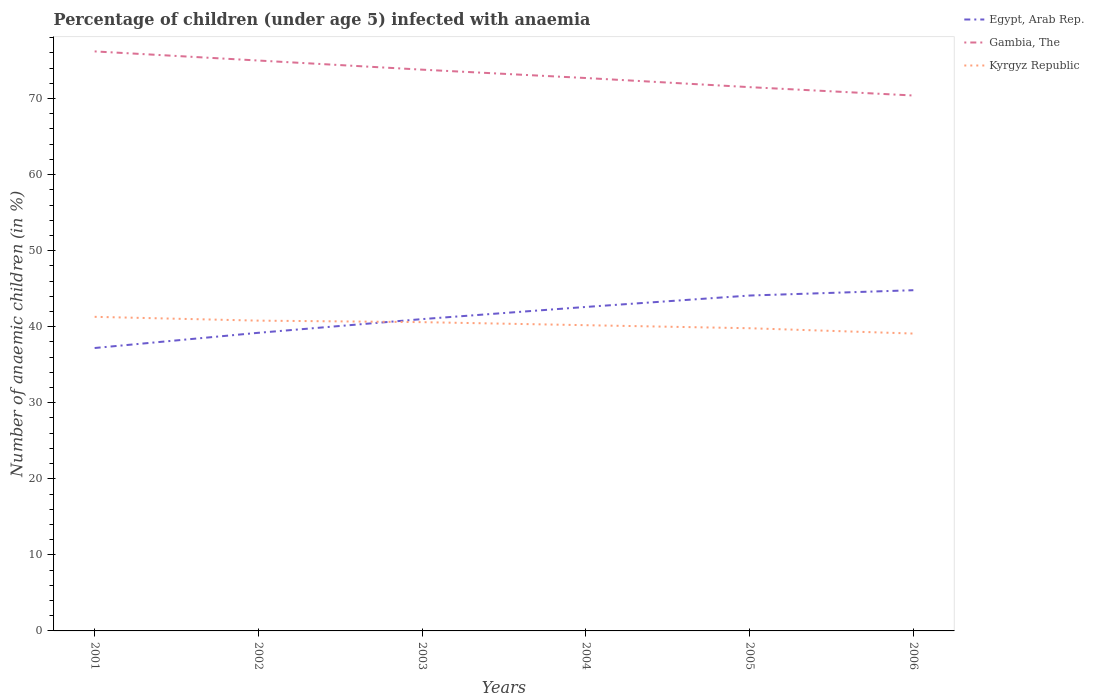How many different coloured lines are there?
Your answer should be compact. 3. Is the number of lines equal to the number of legend labels?
Offer a very short reply. Yes. Across all years, what is the maximum percentage of children infected with anaemia in in Gambia, The?
Keep it short and to the point. 70.4. In which year was the percentage of children infected with anaemia in in Kyrgyz Republic maximum?
Provide a short and direct response. 2006. What is the total percentage of children infected with anaemia in in Kyrgyz Republic in the graph?
Ensure brevity in your answer.  1.1. What is the difference between the highest and the second highest percentage of children infected with anaemia in in Egypt, Arab Rep.?
Provide a succinct answer. 7.6. How many years are there in the graph?
Offer a very short reply. 6. What is the difference between two consecutive major ticks on the Y-axis?
Provide a short and direct response. 10. Are the values on the major ticks of Y-axis written in scientific E-notation?
Ensure brevity in your answer.  No. Does the graph contain any zero values?
Keep it short and to the point. No. How many legend labels are there?
Offer a terse response. 3. What is the title of the graph?
Your response must be concise. Percentage of children (under age 5) infected with anaemia. What is the label or title of the Y-axis?
Give a very brief answer. Number of anaemic children (in %). What is the Number of anaemic children (in %) in Egypt, Arab Rep. in 2001?
Your response must be concise. 37.2. What is the Number of anaemic children (in %) of Gambia, The in 2001?
Offer a terse response. 76.2. What is the Number of anaemic children (in %) of Kyrgyz Republic in 2001?
Offer a very short reply. 41.3. What is the Number of anaemic children (in %) in Egypt, Arab Rep. in 2002?
Offer a terse response. 39.2. What is the Number of anaemic children (in %) in Gambia, The in 2002?
Offer a terse response. 75. What is the Number of anaemic children (in %) of Kyrgyz Republic in 2002?
Ensure brevity in your answer.  40.8. What is the Number of anaemic children (in %) of Egypt, Arab Rep. in 2003?
Ensure brevity in your answer.  41. What is the Number of anaemic children (in %) in Gambia, The in 2003?
Your answer should be very brief. 73.8. What is the Number of anaemic children (in %) of Kyrgyz Republic in 2003?
Your response must be concise. 40.6. What is the Number of anaemic children (in %) of Egypt, Arab Rep. in 2004?
Keep it short and to the point. 42.6. What is the Number of anaemic children (in %) in Gambia, The in 2004?
Your answer should be compact. 72.7. What is the Number of anaemic children (in %) in Kyrgyz Republic in 2004?
Make the answer very short. 40.2. What is the Number of anaemic children (in %) in Egypt, Arab Rep. in 2005?
Provide a succinct answer. 44.1. What is the Number of anaemic children (in %) in Gambia, The in 2005?
Give a very brief answer. 71.5. What is the Number of anaemic children (in %) of Kyrgyz Republic in 2005?
Provide a short and direct response. 39.8. What is the Number of anaemic children (in %) in Egypt, Arab Rep. in 2006?
Make the answer very short. 44.8. What is the Number of anaemic children (in %) in Gambia, The in 2006?
Your answer should be very brief. 70.4. What is the Number of anaemic children (in %) in Kyrgyz Republic in 2006?
Ensure brevity in your answer.  39.1. Across all years, what is the maximum Number of anaemic children (in %) of Egypt, Arab Rep.?
Provide a succinct answer. 44.8. Across all years, what is the maximum Number of anaemic children (in %) in Gambia, The?
Your answer should be very brief. 76.2. Across all years, what is the maximum Number of anaemic children (in %) in Kyrgyz Republic?
Offer a very short reply. 41.3. Across all years, what is the minimum Number of anaemic children (in %) in Egypt, Arab Rep.?
Your answer should be very brief. 37.2. Across all years, what is the minimum Number of anaemic children (in %) in Gambia, The?
Your answer should be compact. 70.4. Across all years, what is the minimum Number of anaemic children (in %) in Kyrgyz Republic?
Make the answer very short. 39.1. What is the total Number of anaemic children (in %) in Egypt, Arab Rep. in the graph?
Your answer should be compact. 248.9. What is the total Number of anaemic children (in %) of Gambia, The in the graph?
Give a very brief answer. 439.6. What is the total Number of anaemic children (in %) of Kyrgyz Republic in the graph?
Keep it short and to the point. 241.8. What is the difference between the Number of anaemic children (in %) of Gambia, The in 2001 and that in 2002?
Make the answer very short. 1.2. What is the difference between the Number of anaemic children (in %) of Gambia, The in 2001 and that in 2003?
Give a very brief answer. 2.4. What is the difference between the Number of anaemic children (in %) in Kyrgyz Republic in 2001 and that in 2004?
Keep it short and to the point. 1.1. What is the difference between the Number of anaemic children (in %) of Kyrgyz Republic in 2001 and that in 2005?
Your answer should be compact. 1.5. What is the difference between the Number of anaemic children (in %) of Kyrgyz Republic in 2001 and that in 2006?
Give a very brief answer. 2.2. What is the difference between the Number of anaemic children (in %) in Egypt, Arab Rep. in 2002 and that in 2004?
Give a very brief answer. -3.4. What is the difference between the Number of anaemic children (in %) in Gambia, The in 2002 and that in 2006?
Provide a short and direct response. 4.6. What is the difference between the Number of anaemic children (in %) in Kyrgyz Republic in 2002 and that in 2006?
Offer a very short reply. 1.7. What is the difference between the Number of anaemic children (in %) in Kyrgyz Republic in 2003 and that in 2004?
Give a very brief answer. 0.4. What is the difference between the Number of anaemic children (in %) of Egypt, Arab Rep. in 2003 and that in 2005?
Your response must be concise. -3.1. What is the difference between the Number of anaemic children (in %) of Gambia, The in 2003 and that in 2005?
Keep it short and to the point. 2.3. What is the difference between the Number of anaemic children (in %) of Kyrgyz Republic in 2003 and that in 2005?
Make the answer very short. 0.8. What is the difference between the Number of anaemic children (in %) of Kyrgyz Republic in 2003 and that in 2006?
Offer a very short reply. 1.5. What is the difference between the Number of anaemic children (in %) in Gambia, The in 2004 and that in 2005?
Ensure brevity in your answer.  1.2. What is the difference between the Number of anaemic children (in %) in Egypt, Arab Rep. in 2004 and that in 2006?
Keep it short and to the point. -2.2. What is the difference between the Number of anaemic children (in %) in Gambia, The in 2004 and that in 2006?
Your answer should be very brief. 2.3. What is the difference between the Number of anaemic children (in %) of Kyrgyz Republic in 2004 and that in 2006?
Your answer should be compact. 1.1. What is the difference between the Number of anaemic children (in %) in Egypt, Arab Rep. in 2001 and the Number of anaemic children (in %) in Gambia, The in 2002?
Your response must be concise. -37.8. What is the difference between the Number of anaemic children (in %) in Gambia, The in 2001 and the Number of anaemic children (in %) in Kyrgyz Republic in 2002?
Give a very brief answer. 35.4. What is the difference between the Number of anaemic children (in %) in Egypt, Arab Rep. in 2001 and the Number of anaemic children (in %) in Gambia, The in 2003?
Offer a terse response. -36.6. What is the difference between the Number of anaemic children (in %) of Egypt, Arab Rep. in 2001 and the Number of anaemic children (in %) of Kyrgyz Republic in 2003?
Give a very brief answer. -3.4. What is the difference between the Number of anaemic children (in %) in Gambia, The in 2001 and the Number of anaemic children (in %) in Kyrgyz Republic in 2003?
Your answer should be very brief. 35.6. What is the difference between the Number of anaemic children (in %) of Egypt, Arab Rep. in 2001 and the Number of anaemic children (in %) of Gambia, The in 2004?
Your response must be concise. -35.5. What is the difference between the Number of anaemic children (in %) in Gambia, The in 2001 and the Number of anaemic children (in %) in Kyrgyz Republic in 2004?
Offer a terse response. 36. What is the difference between the Number of anaemic children (in %) in Egypt, Arab Rep. in 2001 and the Number of anaemic children (in %) in Gambia, The in 2005?
Your answer should be very brief. -34.3. What is the difference between the Number of anaemic children (in %) of Egypt, Arab Rep. in 2001 and the Number of anaemic children (in %) of Kyrgyz Republic in 2005?
Your answer should be compact. -2.6. What is the difference between the Number of anaemic children (in %) in Gambia, The in 2001 and the Number of anaemic children (in %) in Kyrgyz Republic in 2005?
Offer a terse response. 36.4. What is the difference between the Number of anaemic children (in %) in Egypt, Arab Rep. in 2001 and the Number of anaemic children (in %) in Gambia, The in 2006?
Offer a very short reply. -33.2. What is the difference between the Number of anaemic children (in %) of Egypt, Arab Rep. in 2001 and the Number of anaemic children (in %) of Kyrgyz Republic in 2006?
Your answer should be compact. -1.9. What is the difference between the Number of anaemic children (in %) in Gambia, The in 2001 and the Number of anaemic children (in %) in Kyrgyz Republic in 2006?
Provide a short and direct response. 37.1. What is the difference between the Number of anaemic children (in %) in Egypt, Arab Rep. in 2002 and the Number of anaemic children (in %) in Gambia, The in 2003?
Offer a very short reply. -34.6. What is the difference between the Number of anaemic children (in %) in Egypt, Arab Rep. in 2002 and the Number of anaemic children (in %) in Kyrgyz Republic in 2003?
Provide a short and direct response. -1.4. What is the difference between the Number of anaemic children (in %) in Gambia, The in 2002 and the Number of anaemic children (in %) in Kyrgyz Republic in 2003?
Your response must be concise. 34.4. What is the difference between the Number of anaemic children (in %) of Egypt, Arab Rep. in 2002 and the Number of anaemic children (in %) of Gambia, The in 2004?
Ensure brevity in your answer.  -33.5. What is the difference between the Number of anaemic children (in %) of Egypt, Arab Rep. in 2002 and the Number of anaemic children (in %) of Kyrgyz Republic in 2004?
Provide a short and direct response. -1. What is the difference between the Number of anaemic children (in %) in Gambia, The in 2002 and the Number of anaemic children (in %) in Kyrgyz Republic in 2004?
Provide a short and direct response. 34.8. What is the difference between the Number of anaemic children (in %) of Egypt, Arab Rep. in 2002 and the Number of anaemic children (in %) of Gambia, The in 2005?
Keep it short and to the point. -32.3. What is the difference between the Number of anaemic children (in %) of Gambia, The in 2002 and the Number of anaemic children (in %) of Kyrgyz Republic in 2005?
Ensure brevity in your answer.  35.2. What is the difference between the Number of anaemic children (in %) of Egypt, Arab Rep. in 2002 and the Number of anaemic children (in %) of Gambia, The in 2006?
Keep it short and to the point. -31.2. What is the difference between the Number of anaemic children (in %) of Egypt, Arab Rep. in 2002 and the Number of anaemic children (in %) of Kyrgyz Republic in 2006?
Ensure brevity in your answer.  0.1. What is the difference between the Number of anaemic children (in %) in Gambia, The in 2002 and the Number of anaemic children (in %) in Kyrgyz Republic in 2006?
Offer a terse response. 35.9. What is the difference between the Number of anaemic children (in %) in Egypt, Arab Rep. in 2003 and the Number of anaemic children (in %) in Gambia, The in 2004?
Offer a terse response. -31.7. What is the difference between the Number of anaemic children (in %) of Gambia, The in 2003 and the Number of anaemic children (in %) of Kyrgyz Republic in 2004?
Provide a succinct answer. 33.6. What is the difference between the Number of anaemic children (in %) in Egypt, Arab Rep. in 2003 and the Number of anaemic children (in %) in Gambia, The in 2005?
Make the answer very short. -30.5. What is the difference between the Number of anaemic children (in %) of Egypt, Arab Rep. in 2003 and the Number of anaemic children (in %) of Kyrgyz Republic in 2005?
Make the answer very short. 1.2. What is the difference between the Number of anaemic children (in %) in Gambia, The in 2003 and the Number of anaemic children (in %) in Kyrgyz Republic in 2005?
Offer a terse response. 34. What is the difference between the Number of anaemic children (in %) in Egypt, Arab Rep. in 2003 and the Number of anaemic children (in %) in Gambia, The in 2006?
Make the answer very short. -29.4. What is the difference between the Number of anaemic children (in %) of Egypt, Arab Rep. in 2003 and the Number of anaemic children (in %) of Kyrgyz Republic in 2006?
Provide a succinct answer. 1.9. What is the difference between the Number of anaemic children (in %) in Gambia, The in 2003 and the Number of anaemic children (in %) in Kyrgyz Republic in 2006?
Provide a succinct answer. 34.7. What is the difference between the Number of anaemic children (in %) in Egypt, Arab Rep. in 2004 and the Number of anaemic children (in %) in Gambia, The in 2005?
Ensure brevity in your answer.  -28.9. What is the difference between the Number of anaemic children (in %) in Gambia, The in 2004 and the Number of anaemic children (in %) in Kyrgyz Republic in 2005?
Keep it short and to the point. 32.9. What is the difference between the Number of anaemic children (in %) in Egypt, Arab Rep. in 2004 and the Number of anaemic children (in %) in Gambia, The in 2006?
Your response must be concise. -27.8. What is the difference between the Number of anaemic children (in %) in Gambia, The in 2004 and the Number of anaemic children (in %) in Kyrgyz Republic in 2006?
Offer a very short reply. 33.6. What is the difference between the Number of anaemic children (in %) of Egypt, Arab Rep. in 2005 and the Number of anaemic children (in %) of Gambia, The in 2006?
Your answer should be very brief. -26.3. What is the difference between the Number of anaemic children (in %) of Gambia, The in 2005 and the Number of anaemic children (in %) of Kyrgyz Republic in 2006?
Offer a terse response. 32.4. What is the average Number of anaemic children (in %) in Egypt, Arab Rep. per year?
Keep it short and to the point. 41.48. What is the average Number of anaemic children (in %) of Gambia, The per year?
Your response must be concise. 73.27. What is the average Number of anaemic children (in %) of Kyrgyz Republic per year?
Your answer should be very brief. 40.3. In the year 2001, what is the difference between the Number of anaemic children (in %) in Egypt, Arab Rep. and Number of anaemic children (in %) in Gambia, The?
Provide a short and direct response. -39. In the year 2001, what is the difference between the Number of anaemic children (in %) in Egypt, Arab Rep. and Number of anaemic children (in %) in Kyrgyz Republic?
Offer a terse response. -4.1. In the year 2001, what is the difference between the Number of anaemic children (in %) of Gambia, The and Number of anaemic children (in %) of Kyrgyz Republic?
Offer a very short reply. 34.9. In the year 2002, what is the difference between the Number of anaemic children (in %) of Egypt, Arab Rep. and Number of anaemic children (in %) of Gambia, The?
Offer a terse response. -35.8. In the year 2002, what is the difference between the Number of anaemic children (in %) in Gambia, The and Number of anaemic children (in %) in Kyrgyz Republic?
Make the answer very short. 34.2. In the year 2003, what is the difference between the Number of anaemic children (in %) of Egypt, Arab Rep. and Number of anaemic children (in %) of Gambia, The?
Your answer should be very brief. -32.8. In the year 2003, what is the difference between the Number of anaemic children (in %) of Gambia, The and Number of anaemic children (in %) of Kyrgyz Republic?
Your answer should be very brief. 33.2. In the year 2004, what is the difference between the Number of anaemic children (in %) in Egypt, Arab Rep. and Number of anaemic children (in %) in Gambia, The?
Your answer should be very brief. -30.1. In the year 2004, what is the difference between the Number of anaemic children (in %) in Egypt, Arab Rep. and Number of anaemic children (in %) in Kyrgyz Republic?
Make the answer very short. 2.4. In the year 2004, what is the difference between the Number of anaemic children (in %) of Gambia, The and Number of anaemic children (in %) of Kyrgyz Republic?
Offer a terse response. 32.5. In the year 2005, what is the difference between the Number of anaemic children (in %) in Egypt, Arab Rep. and Number of anaemic children (in %) in Gambia, The?
Your answer should be compact. -27.4. In the year 2005, what is the difference between the Number of anaemic children (in %) in Egypt, Arab Rep. and Number of anaemic children (in %) in Kyrgyz Republic?
Ensure brevity in your answer.  4.3. In the year 2005, what is the difference between the Number of anaemic children (in %) in Gambia, The and Number of anaemic children (in %) in Kyrgyz Republic?
Make the answer very short. 31.7. In the year 2006, what is the difference between the Number of anaemic children (in %) of Egypt, Arab Rep. and Number of anaemic children (in %) of Gambia, The?
Provide a succinct answer. -25.6. In the year 2006, what is the difference between the Number of anaemic children (in %) in Egypt, Arab Rep. and Number of anaemic children (in %) in Kyrgyz Republic?
Ensure brevity in your answer.  5.7. In the year 2006, what is the difference between the Number of anaemic children (in %) in Gambia, The and Number of anaemic children (in %) in Kyrgyz Republic?
Offer a terse response. 31.3. What is the ratio of the Number of anaemic children (in %) of Egypt, Arab Rep. in 2001 to that in 2002?
Ensure brevity in your answer.  0.95. What is the ratio of the Number of anaemic children (in %) in Kyrgyz Republic in 2001 to that in 2002?
Provide a succinct answer. 1.01. What is the ratio of the Number of anaemic children (in %) in Egypt, Arab Rep. in 2001 to that in 2003?
Give a very brief answer. 0.91. What is the ratio of the Number of anaemic children (in %) of Gambia, The in 2001 to that in 2003?
Ensure brevity in your answer.  1.03. What is the ratio of the Number of anaemic children (in %) in Kyrgyz Republic in 2001 to that in 2003?
Give a very brief answer. 1.02. What is the ratio of the Number of anaemic children (in %) of Egypt, Arab Rep. in 2001 to that in 2004?
Give a very brief answer. 0.87. What is the ratio of the Number of anaemic children (in %) of Gambia, The in 2001 to that in 2004?
Offer a terse response. 1.05. What is the ratio of the Number of anaemic children (in %) of Kyrgyz Republic in 2001 to that in 2004?
Offer a terse response. 1.03. What is the ratio of the Number of anaemic children (in %) of Egypt, Arab Rep. in 2001 to that in 2005?
Provide a succinct answer. 0.84. What is the ratio of the Number of anaemic children (in %) in Gambia, The in 2001 to that in 2005?
Give a very brief answer. 1.07. What is the ratio of the Number of anaemic children (in %) of Kyrgyz Republic in 2001 to that in 2005?
Make the answer very short. 1.04. What is the ratio of the Number of anaemic children (in %) of Egypt, Arab Rep. in 2001 to that in 2006?
Ensure brevity in your answer.  0.83. What is the ratio of the Number of anaemic children (in %) of Gambia, The in 2001 to that in 2006?
Provide a short and direct response. 1.08. What is the ratio of the Number of anaemic children (in %) of Kyrgyz Republic in 2001 to that in 2006?
Give a very brief answer. 1.06. What is the ratio of the Number of anaemic children (in %) of Egypt, Arab Rep. in 2002 to that in 2003?
Offer a terse response. 0.96. What is the ratio of the Number of anaemic children (in %) in Gambia, The in 2002 to that in 2003?
Offer a very short reply. 1.02. What is the ratio of the Number of anaemic children (in %) in Egypt, Arab Rep. in 2002 to that in 2004?
Keep it short and to the point. 0.92. What is the ratio of the Number of anaemic children (in %) in Gambia, The in 2002 to that in 2004?
Your answer should be compact. 1.03. What is the ratio of the Number of anaemic children (in %) in Kyrgyz Republic in 2002 to that in 2004?
Your response must be concise. 1.01. What is the ratio of the Number of anaemic children (in %) of Egypt, Arab Rep. in 2002 to that in 2005?
Give a very brief answer. 0.89. What is the ratio of the Number of anaemic children (in %) in Gambia, The in 2002 to that in 2005?
Give a very brief answer. 1.05. What is the ratio of the Number of anaemic children (in %) in Kyrgyz Republic in 2002 to that in 2005?
Give a very brief answer. 1.03. What is the ratio of the Number of anaemic children (in %) in Egypt, Arab Rep. in 2002 to that in 2006?
Provide a succinct answer. 0.88. What is the ratio of the Number of anaemic children (in %) of Gambia, The in 2002 to that in 2006?
Keep it short and to the point. 1.07. What is the ratio of the Number of anaemic children (in %) of Kyrgyz Republic in 2002 to that in 2006?
Provide a succinct answer. 1.04. What is the ratio of the Number of anaemic children (in %) in Egypt, Arab Rep. in 2003 to that in 2004?
Provide a succinct answer. 0.96. What is the ratio of the Number of anaemic children (in %) in Gambia, The in 2003 to that in 2004?
Your answer should be compact. 1.02. What is the ratio of the Number of anaemic children (in %) of Egypt, Arab Rep. in 2003 to that in 2005?
Ensure brevity in your answer.  0.93. What is the ratio of the Number of anaemic children (in %) of Gambia, The in 2003 to that in 2005?
Provide a short and direct response. 1.03. What is the ratio of the Number of anaemic children (in %) in Kyrgyz Republic in 2003 to that in 2005?
Offer a very short reply. 1.02. What is the ratio of the Number of anaemic children (in %) in Egypt, Arab Rep. in 2003 to that in 2006?
Offer a terse response. 0.92. What is the ratio of the Number of anaemic children (in %) in Gambia, The in 2003 to that in 2006?
Your answer should be very brief. 1.05. What is the ratio of the Number of anaemic children (in %) of Kyrgyz Republic in 2003 to that in 2006?
Keep it short and to the point. 1.04. What is the ratio of the Number of anaemic children (in %) in Gambia, The in 2004 to that in 2005?
Your response must be concise. 1.02. What is the ratio of the Number of anaemic children (in %) in Egypt, Arab Rep. in 2004 to that in 2006?
Your response must be concise. 0.95. What is the ratio of the Number of anaemic children (in %) in Gambia, The in 2004 to that in 2006?
Your answer should be compact. 1.03. What is the ratio of the Number of anaemic children (in %) in Kyrgyz Republic in 2004 to that in 2006?
Keep it short and to the point. 1.03. What is the ratio of the Number of anaemic children (in %) in Egypt, Arab Rep. in 2005 to that in 2006?
Make the answer very short. 0.98. What is the ratio of the Number of anaemic children (in %) of Gambia, The in 2005 to that in 2006?
Offer a very short reply. 1.02. What is the ratio of the Number of anaemic children (in %) of Kyrgyz Republic in 2005 to that in 2006?
Keep it short and to the point. 1.02. What is the difference between the highest and the second highest Number of anaemic children (in %) of Gambia, The?
Your answer should be compact. 1.2. What is the difference between the highest and the second highest Number of anaemic children (in %) of Kyrgyz Republic?
Offer a very short reply. 0.5. What is the difference between the highest and the lowest Number of anaemic children (in %) of Gambia, The?
Give a very brief answer. 5.8. What is the difference between the highest and the lowest Number of anaemic children (in %) in Kyrgyz Republic?
Offer a terse response. 2.2. 